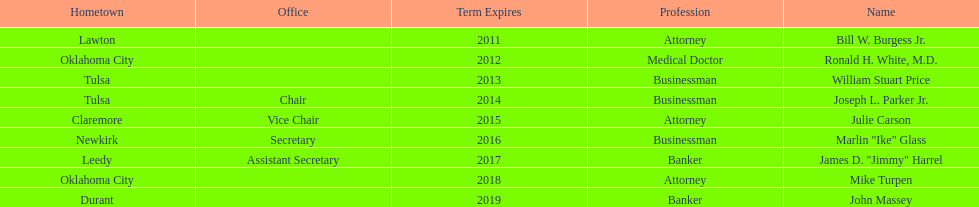What is the count of state regents with terms extending to 2016 or later? 4. Give me the full table as a dictionary. {'header': ['Hometown', 'Office', 'Term Expires', 'Profession', 'Name'], 'rows': [['Lawton', '', '2011', 'Attorney', 'Bill W. Burgess Jr.'], ['Oklahoma City', '', '2012', 'Medical Doctor', 'Ronald H. White, M.D.'], ['Tulsa', '', '2013', 'Businessman', 'William Stuart Price'], ['Tulsa', 'Chair', '2014', 'Businessman', 'Joseph L. Parker Jr.'], ['Claremore', 'Vice Chair', '2015', 'Attorney', 'Julie Carson'], ['Newkirk', 'Secretary', '2016', 'Businessman', 'Marlin "Ike" Glass'], ['Leedy', 'Assistant Secretary', '2017', 'Banker', 'James D. "Jimmy" Harrel'], ['Oklahoma City', '', '2018', 'Attorney', 'Mike Turpen'], ['Durant', '', '2019', 'Banker', 'John Massey']]} 